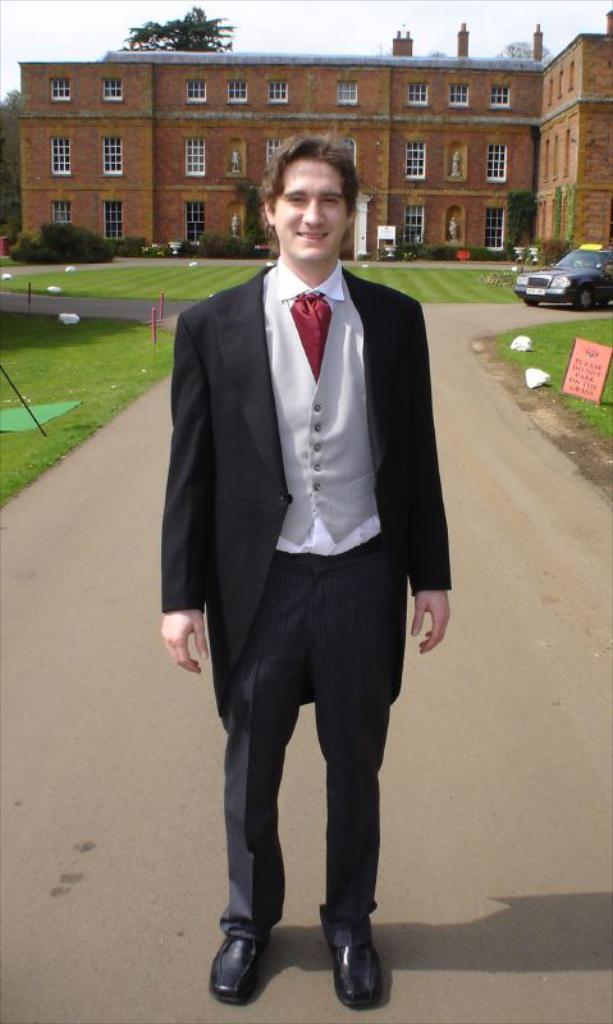Describe this image in one or two sentences. This picture might be taken outside of the city and it is very sunny. In this image, in the middle, we can see a man wearing a black color suit is standing on the road. On the right side of the image, we can see a car and a hoarding. In the background, we can see a building, windows, trees, plants. On the top there is a sky, at the bottom there is a grass and a road. 